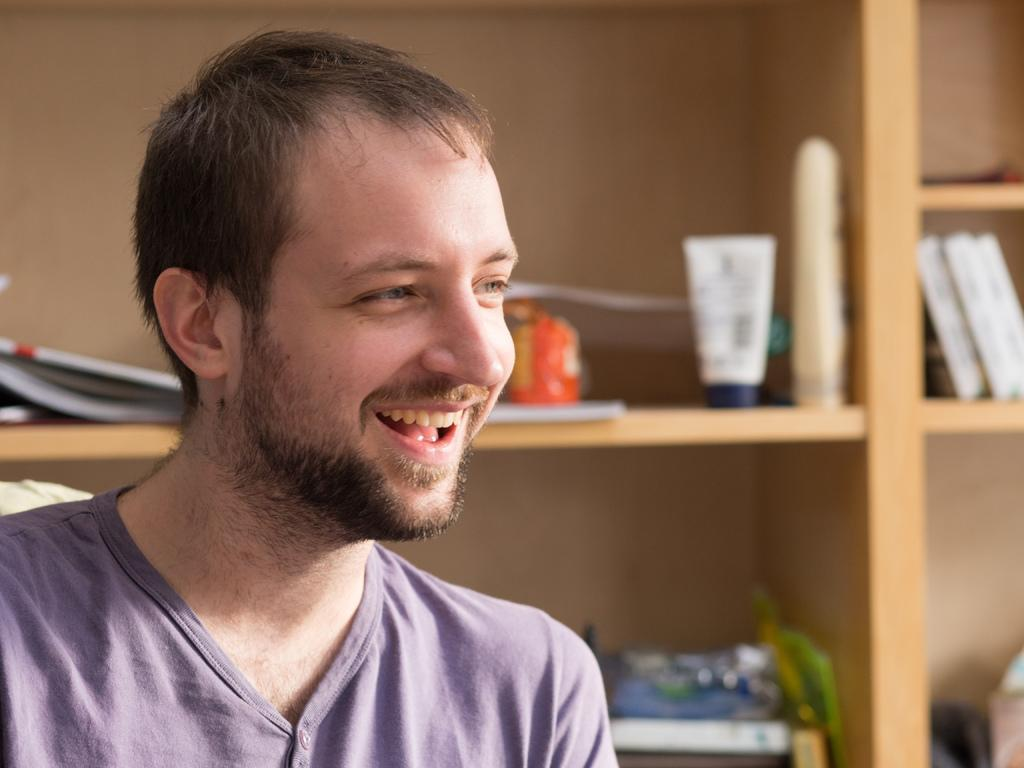Where was the image taken? The image was taken indoors. What can be seen in the foreground of the image? There is a man in the foreground of the image. What is the man's expression in the image? The man is smiling. What is visible in the background of the image? There is a wooden cabinet in the background of the image. What items are stored in the wooden cabinet? The cabinet contains books, bottles, and other objects. What type of yoke is visible in the image? There is no yoke present in the image. What time of day is it in the image? The time of day cannot be determined from the image alone. 